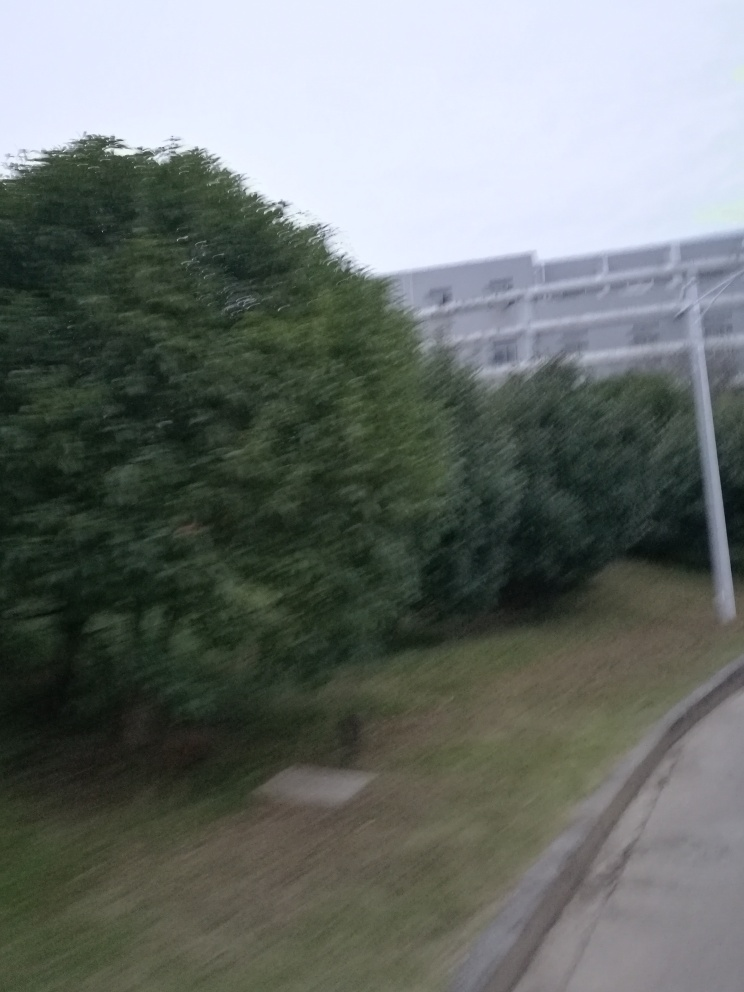How could one improve the sharpness of a photo like this in the future? Improving the sharpness of a photo like this involves stabilizing the camera with a tripod or steady surface to prevent shake, using faster shutter speeds to capture motion more crisply, ensuring the camera is focused on the intended subject, and increasing the ISO setting if in low-light conditions while being mindful of the potential for increased noise. Additionally, using higher-quality cameras with better sensors can also help achieve a clearer, sharper image. 